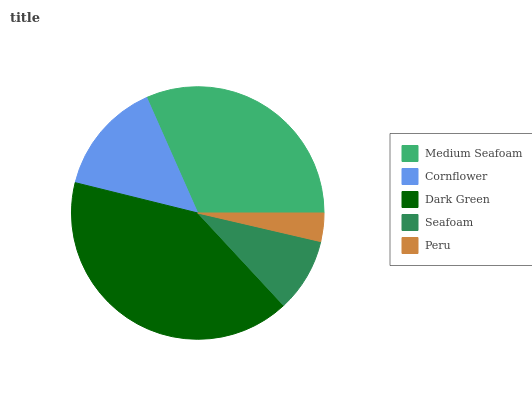Is Peru the minimum?
Answer yes or no. Yes. Is Dark Green the maximum?
Answer yes or no. Yes. Is Cornflower the minimum?
Answer yes or no. No. Is Cornflower the maximum?
Answer yes or no. No. Is Medium Seafoam greater than Cornflower?
Answer yes or no. Yes. Is Cornflower less than Medium Seafoam?
Answer yes or no. Yes. Is Cornflower greater than Medium Seafoam?
Answer yes or no. No. Is Medium Seafoam less than Cornflower?
Answer yes or no. No. Is Cornflower the high median?
Answer yes or no. Yes. Is Cornflower the low median?
Answer yes or no. Yes. Is Medium Seafoam the high median?
Answer yes or no. No. Is Peru the low median?
Answer yes or no. No. 